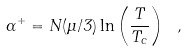<formula> <loc_0><loc_0><loc_500><loc_500>\alpha ^ { + } = N ( \mu / 3 ) \ln \left ( \frac { T } { T _ { c } } \right ) \ ,</formula> 